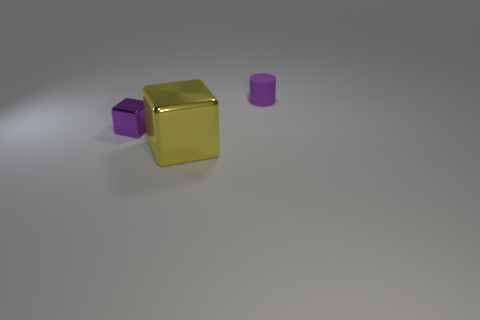What number of other objects are the same shape as the small purple shiny thing?
Give a very brief answer. 1. How many cubes are big yellow shiny objects or small metal objects?
Offer a terse response. 2. There is a tiny thing in front of the tiny thing that is right of the large yellow cube; are there any metallic objects that are in front of it?
Make the answer very short. Yes. What color is the other object that is the same shape as the small metal object?
Give a very brief answer. Yellow. How many red objects are rubber cylinders or large metal balls?
Provide a short and direct response. 0. What is the block that is to the left of the metal thing that is in front of the purple cube made of?
Provide a short and direct response. Metal. Do the yellow object and the purple metal object have the same shape?
Offer a very short reply. Yes. What is the color of the block that is the same size as the purple cylinder?
Offer a terse response. Purple. Is there a shiny cube of the same color as the small matte cylinder?
Offer a terse response. Yes. Is there a yellow matte sphere?
Your answer should be very brief. No. 